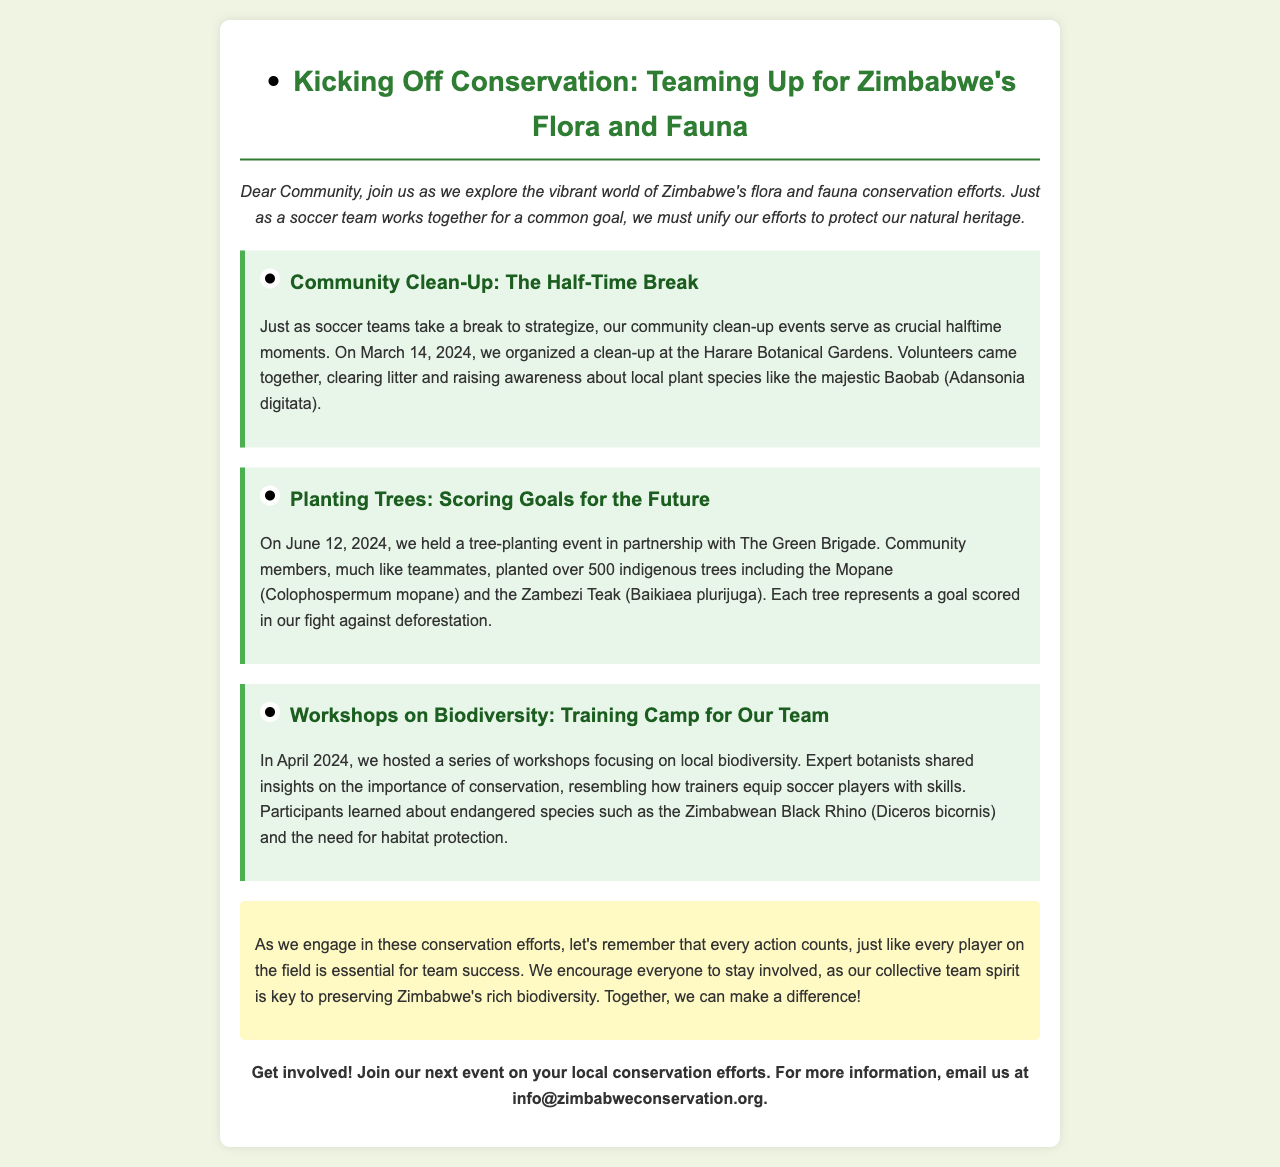What is the title of the newsletter? The title of the newsletter highlights teamwork in conservation efforts, which is found at the beginning of the document.
Answer: Kicking Off Conservation: Teaming Up for Zimbabwe's Flora and Fauna When is the community clean-up event scheduled? The clean-up event date is mentioned in the highlight section about the community clean-up, indicating its importance.
Answer: March 14, 2024 How many indigenous trees were planted during the event? The number of trees is specified in the highlight about tree planting, showing the community's contribution to conservation.
Answer: 500 What endangered species was discussed during the workshops? The endangered species mentioned in the workshops highlight represents important local biodiversity in conservation efforts.
Answer: Zimbabwean Black Rhino What does each tree planted represent? The significance of each tree planted is framed in a way that relates to a common success metric in soccer.
Answer: A goal scored What is the purpose of community clean-up events compared to soccer? This comparison makes a connection to sports strategy, explaining the concept of teamwork and review phases.
Answer: Halftime moments What is the email address for more information? The contact information for further engagement and details about events is provided towards the end of the document.
Answer: info@zimbabweconservation.org 